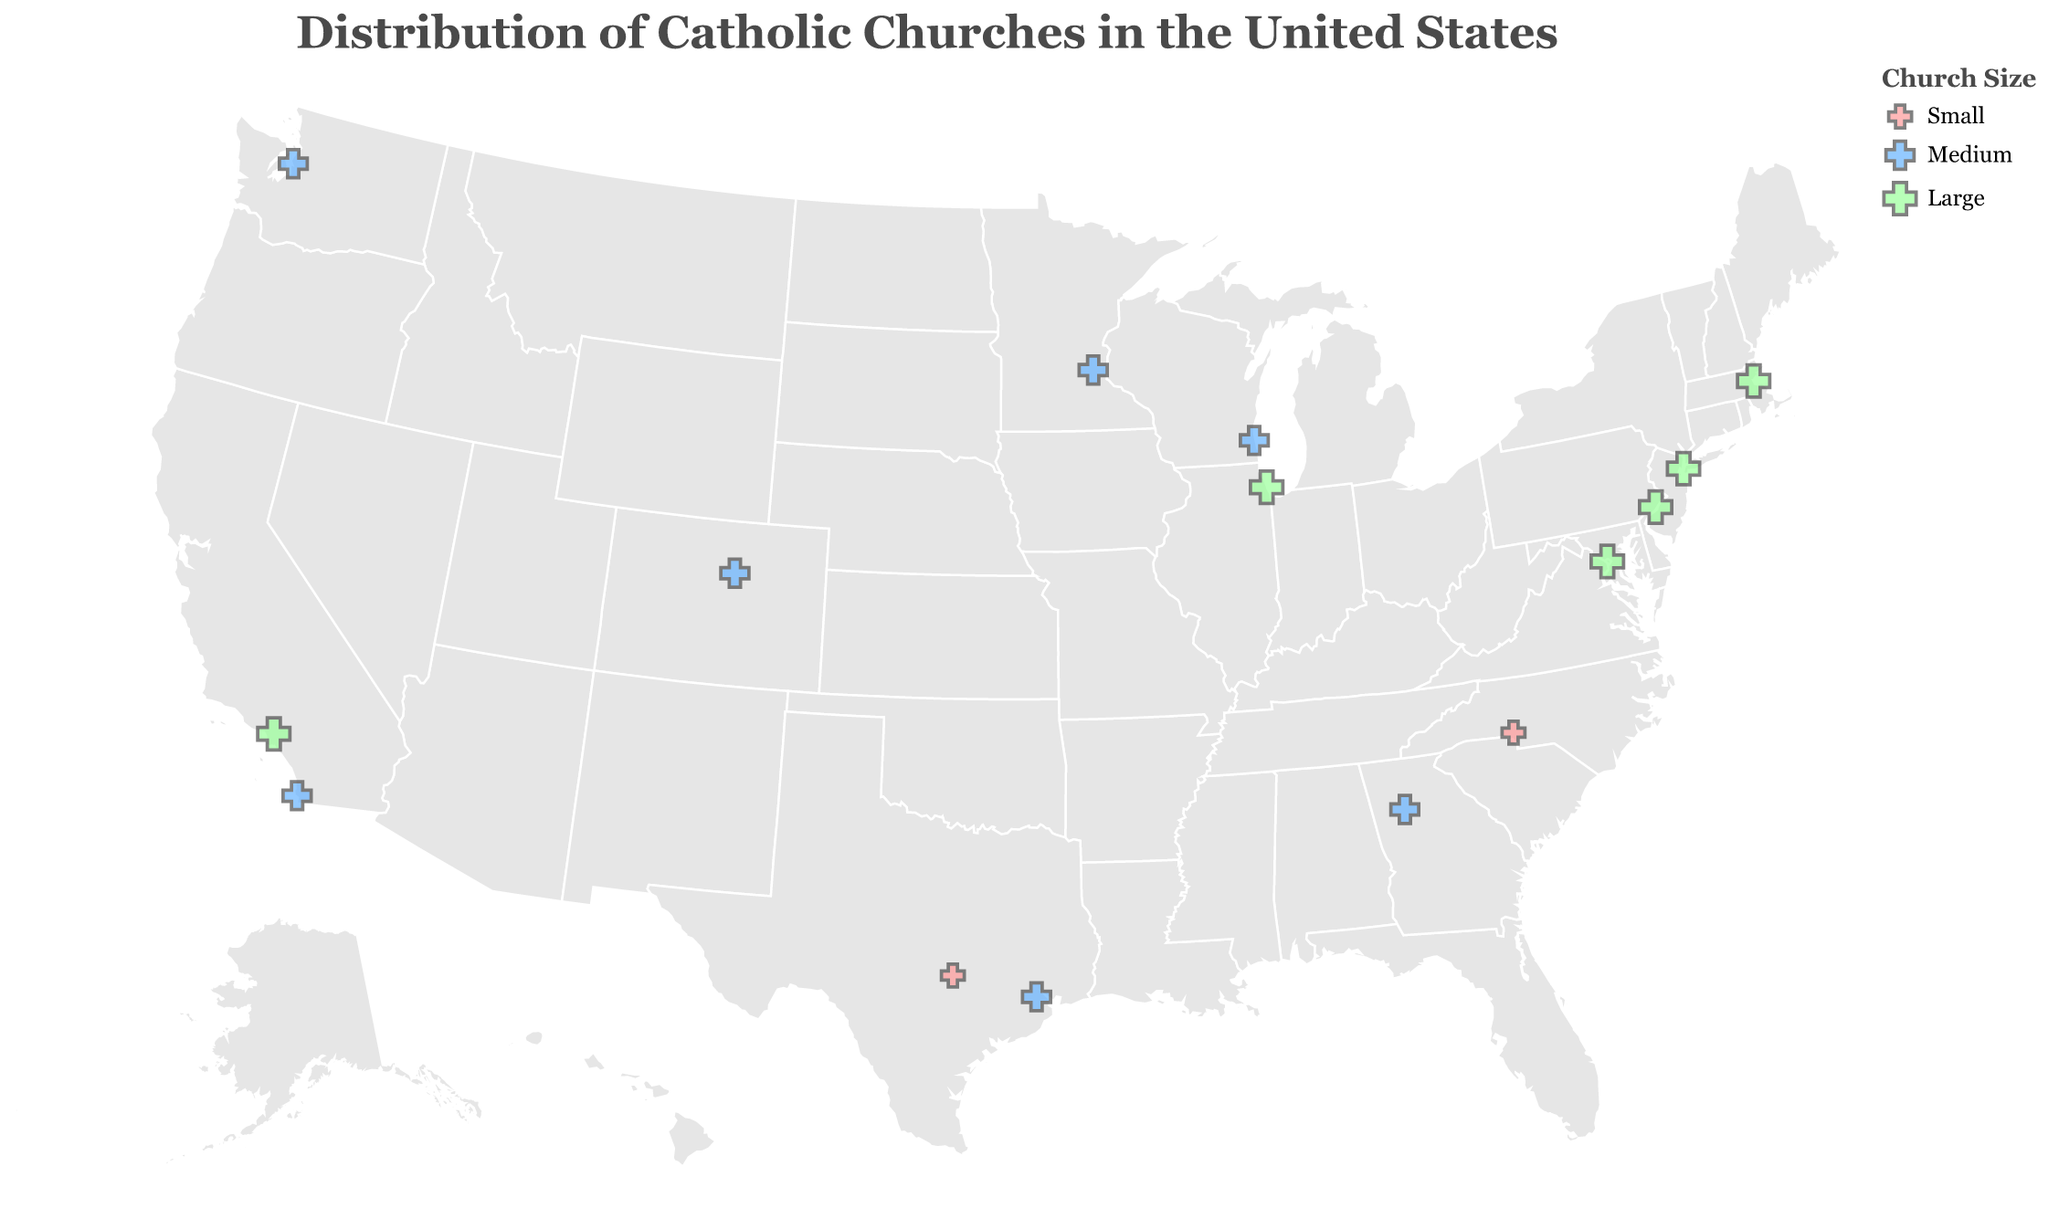How is the title of this plot worded? The title of the plot is displayed in the figure and it reads "Distribution of Catholic Churches in the United States".
Answer: Distribution of Catholic Churches in the United States How many Catholic churches are plotted on the map? By counting the number of points plotted on the map, we can determine the total number of Catholic churches represented. The figure shows 15 points, each representing a church.
Answer: 15 Which cities have the largest Catholic churches? Larger churches are represented by larger points in the figure. The cities with the largest points are Boston, New York, Los Angeles, Chicago, Philadelphia, and Washington D.C.
Answer: Boston, New York, Los Angeles, Chicago, Philadelphia, Washington D.C Which church is located in Houston and what is its size? By looking at the tooltip information over the point in Houston, the church is "Co-Cathedral of the Sacred Heart" and it is of Medium size.
Answer: Co-Cathedral of the Sacred Heart, Medium Are there more medium-sized or small-sized churches on the map? To answer this, count the number of points corresponding to medium-sized (colored in blue) and small-sized (colored in pink) churches. There are 8 medium-sized churches and 2 small-sized churches.
Answer: Medium-sized What is the total number of large-sized churches depicted on the map? By counting the number of points corresponding to large-sized churches (colored in green), we can determine there are 7 such churches.
Answer: 7 What is the key visual distinction between churches of different sizes? The size of the points on the map represents the size of the churches, with larger points indicating larger churches. Additionally, the colors differentiate them: red for small, blue for medium, and green for large.
Answer: Point size and color Which diocese has the most number of medium-sized churches and how many are there? To answer this, identify the diocese associated with each medium-sized church and count them. Multiple dioceses have medium-sized churches, but no diocese has more than one depicted church, so they all have an equal number.
Answer: All have equal numbers Is there any region with a notable absence of depicted Catholic churches in the US? Observing the distribution on the map, there is a noticeable absence of Catholic churches depicted in the central north states around the Great Plains region of the United States.
Answer: Great Plains region 